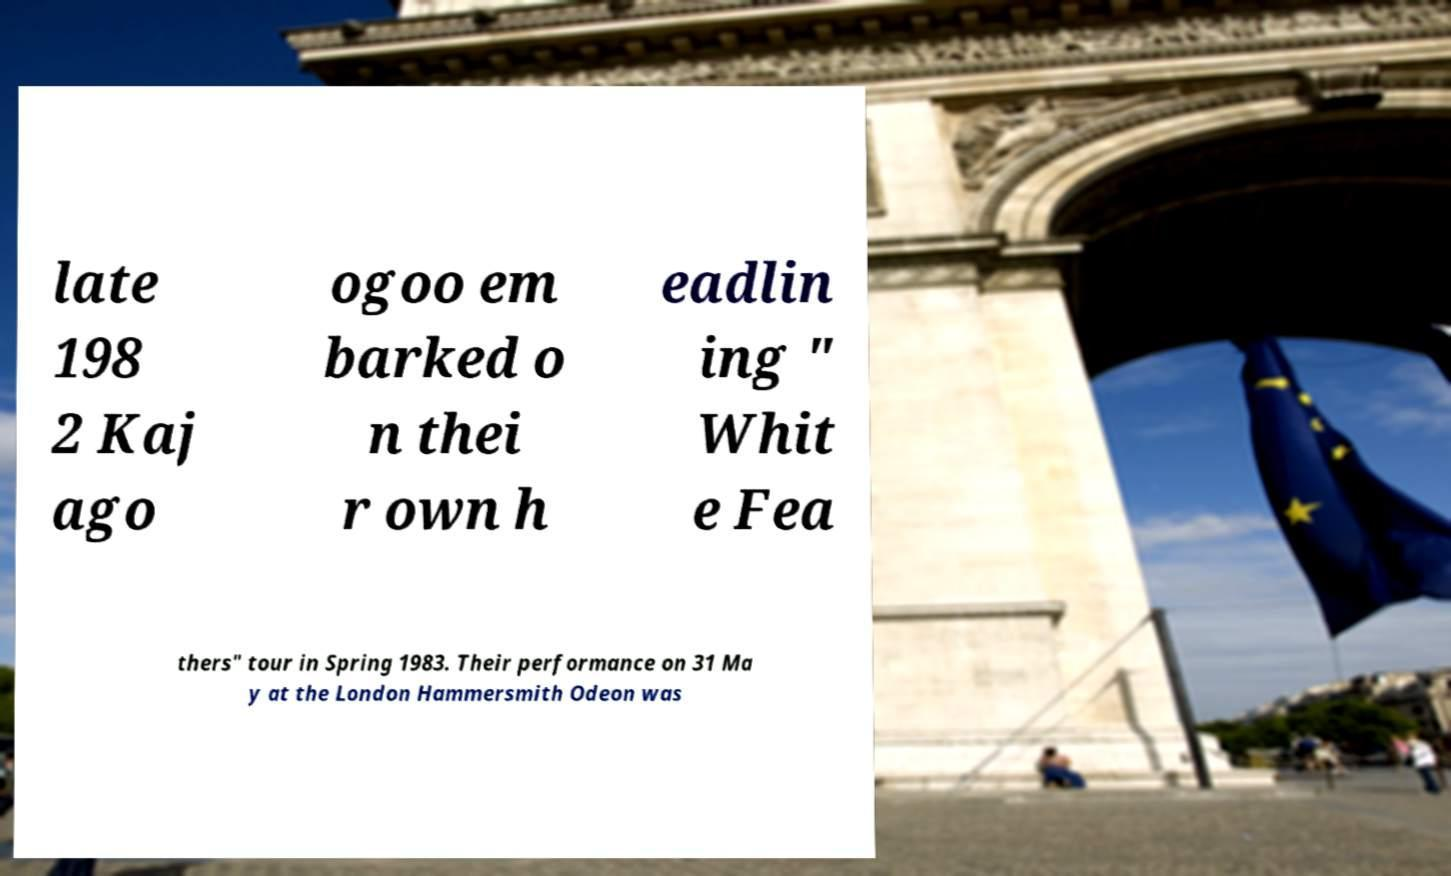Please identify and transcribe the text found in this image. late 198 2 Kaj ago ogoo em barked o n thei r own h eadlin ing " Whit e Fea thers" tour in Spring 1983. Their performance on 31 Ma y at the London Hammersmith Odeon was 